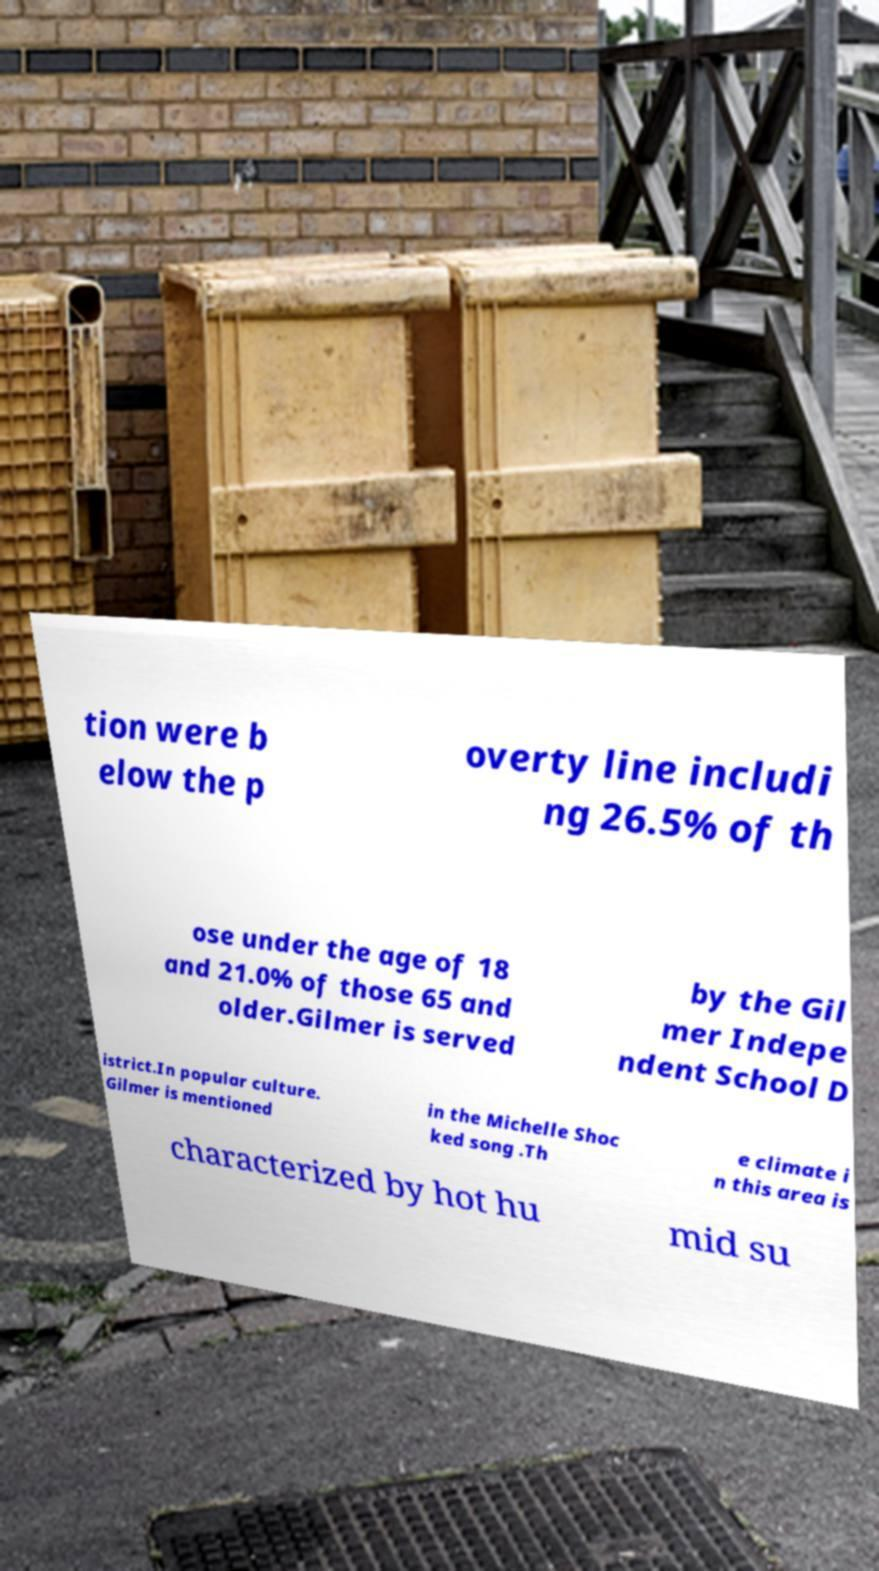Can you read and provide the text displayed in the image?This photo seems to have some interesting text. Can you extract and type it out for me? tion were b elow the p overty line includi ng 26.5% of th ose under the age of 18 and 21.0% of those 65 and older.Gilmer is served by the Gil mer Indepe ndent School D istrict.In popular culture. Gilmer is mentioned in the Michelle Shoc ked song .Th e climate i n this area is characterized by hot hu mid su 